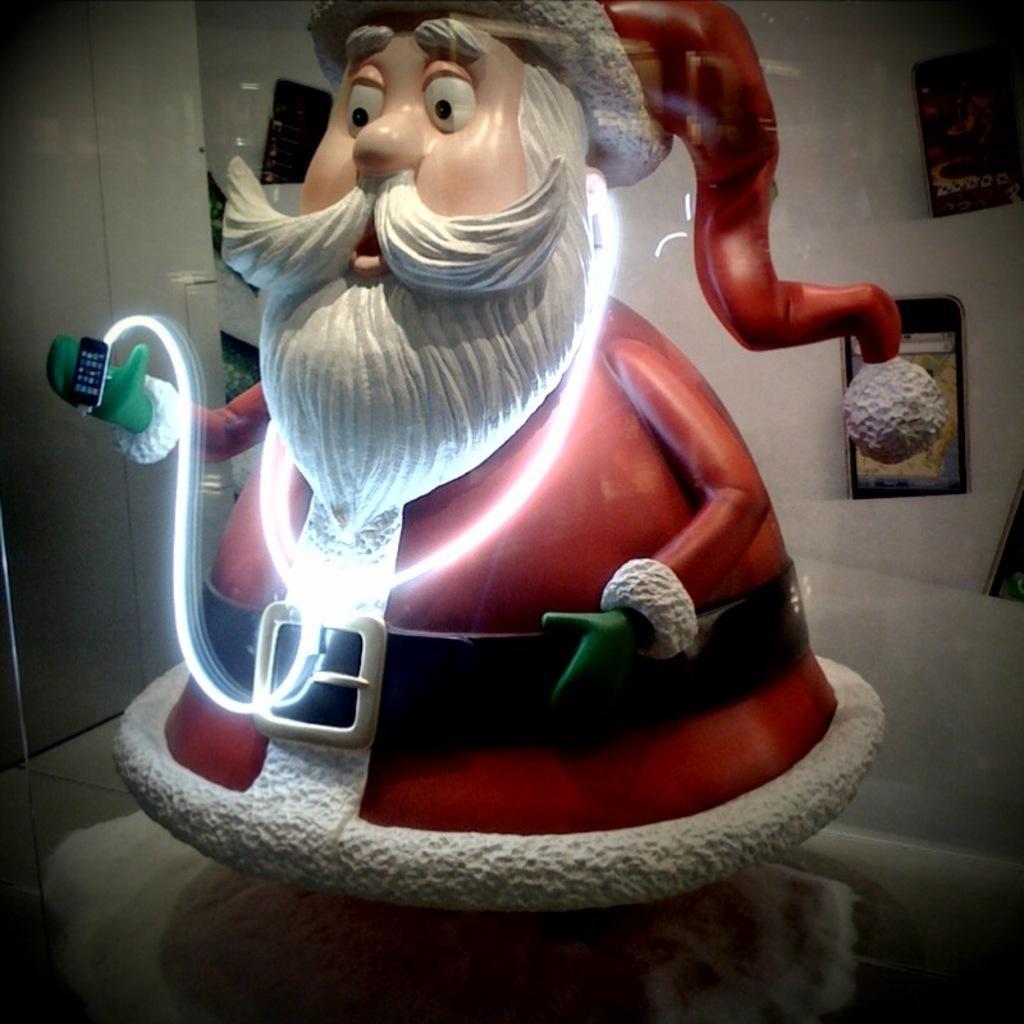Please provide a concise description of this image. In this image I can see the toy santa is holding the mobile. I can see few mobiles on the white color surface. 